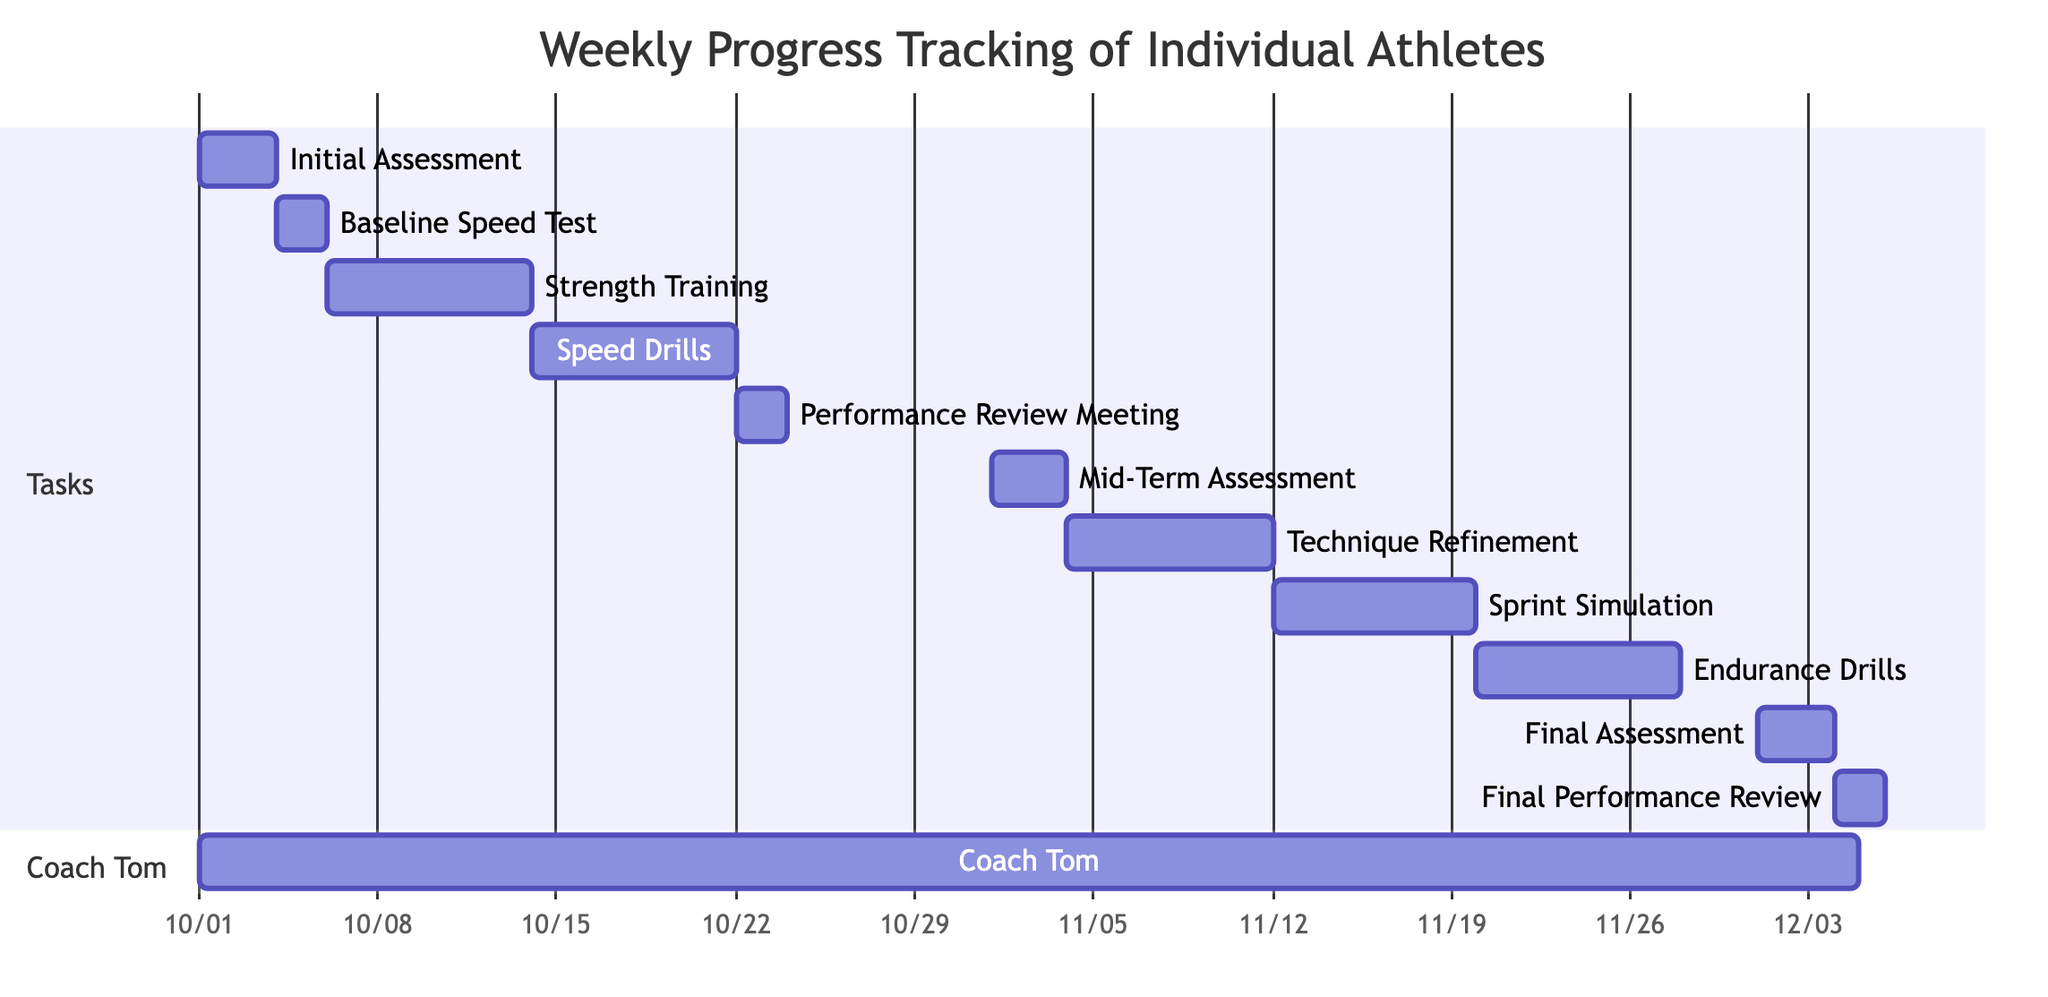what is the duration of the Initial Assessment task? The Initial Assessment task starts on October 1, 2023, and ends on October 3, 2023. The duration is calculated by subtracting the start date from the end date, which results in 3 days.
Answer: 3 days who is the assignee for the Speed Drills task? The Speed Drills task is assigned to Coach Tom. This can be seen in the task list where each task includes the name of the assignee alongside the task details.
Answer: Coach Tom how many tasks are dependent on the Performance Review Meeting? The Performance Review Meeting task has one subsequent task, which is the Mid-Term Assessment. By analyzing the dependencies, we see it only links to one task (Mid-Term Assessment).
Answer: 1 task which task starts immediately after the Strength Training? The Strength Training task ends on October 13, 2023, and the subsequent task, Speed Drills, starts on October 14, 2023. This connection is established by looking at the dependency links showing the order.
Answer: Speed Drills what is the start date of the Final Assessment task? The Final Assessment task is scheduled to start on December 1, 2023. This is directly indicated in the task details of the Gantt Chart, which shows the exact start date for each task.
Answer: December 1, 2023 how many total tasks are planned in this project? The project consists of a total of 11 tasks, as listed in the tasks section of the data provided. Each task is clearly enumerated, leading to the total count.
Answer: 11 tasks what is the overall timeline for this project? The project timeline begins on October 1, 2023, and ends on December 5, 2023. This is determined by looking at the start and end dates of the overall project and the individual tasks which are bounded within these dates.
Answer: October 1 to December 5, 2023 which task has the longest duration? The Strength Training and Endurance Drills tasks each last for 8 days, while other tasks have shorter durations. Comparing all listed task durations reveals these two have the maximum length.
Answer: Strength Training and Endurance Drills 